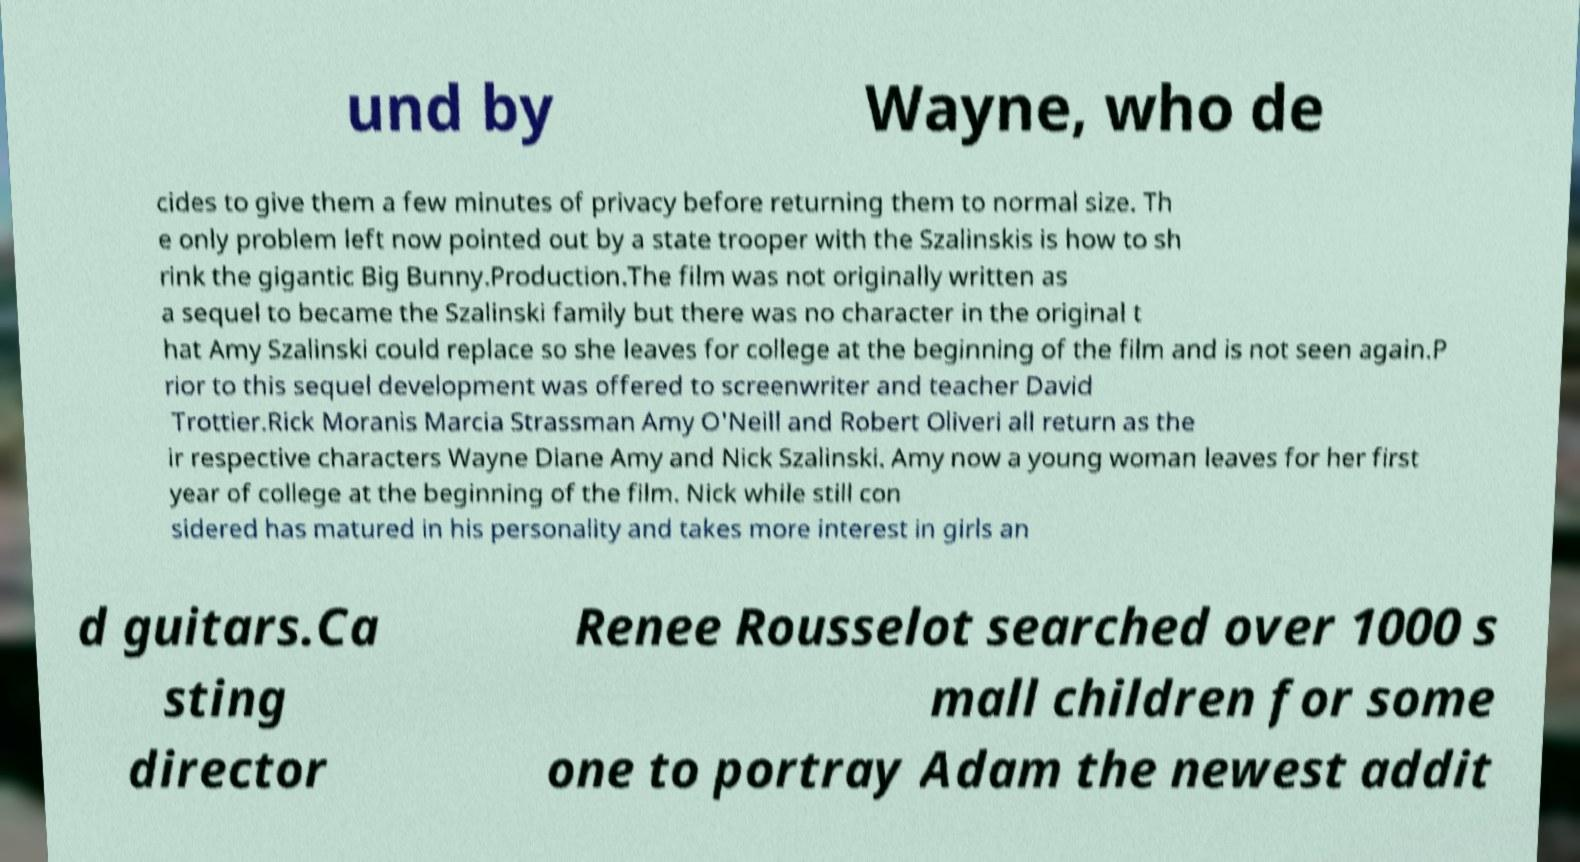Can you accurately transcribe the text from the provided image for me? und by Wayne, who de cides to give them a few minutes of privacy before returning them to normal size. Th e only problem left now pointed out by a state trooper with the Szalinskis is how to sh rink the gigantic Big Bunny.Production.The film was not originally written as a sequel to became the Szalinski family but there was no character in the original t hat Amy Szalinski could replace so she leaves for college at the beginning of the film and is not seen again.P rior to this sequel development was offered to screenwriter and teacher David Trottier.Rick Moranis Marcia Strassman Amy O'Neill and Robert Oliveri all return as the ir respective characters Wayne Diane Amy and Nick Szalinski. Amy now a young woman leaves for her first year of college at the beginning of the film. Nick while still con sidered has matured in his personality and takes more interest in girls an d guitars.Ca sting director Renee Rousselot searched over 1000 s mall children for some one to portray Adam the newest addit 